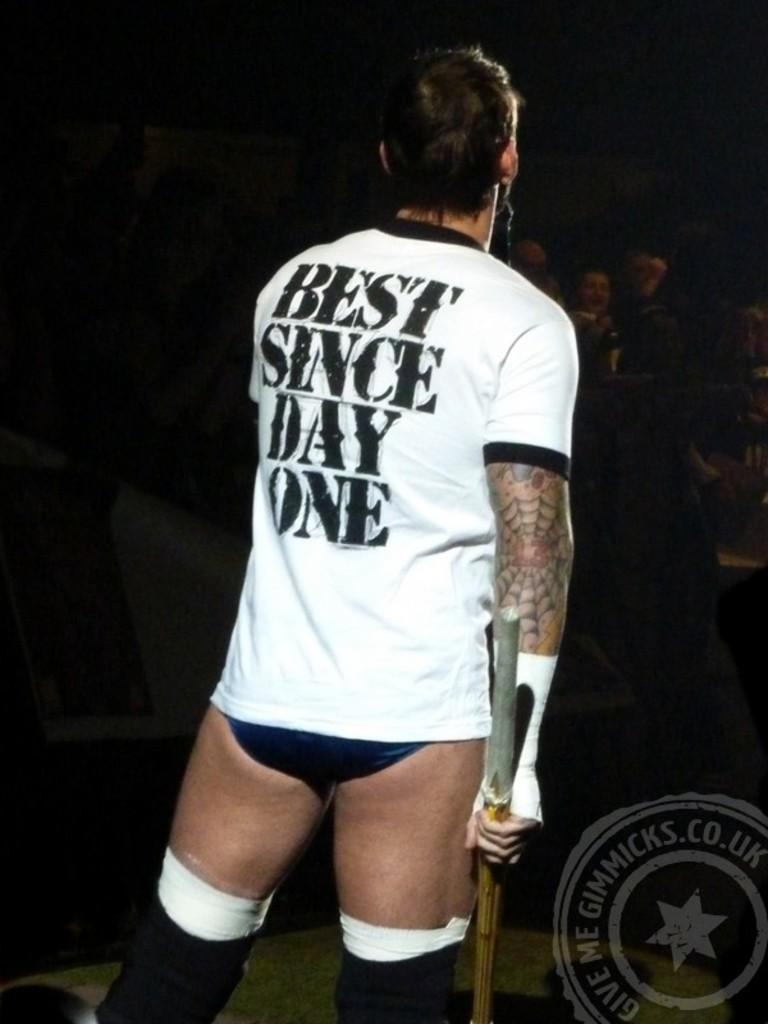<image>
Offer a succinct explanation of the picture presented. A guy in a white shirt that says "best since day one" on the back. 